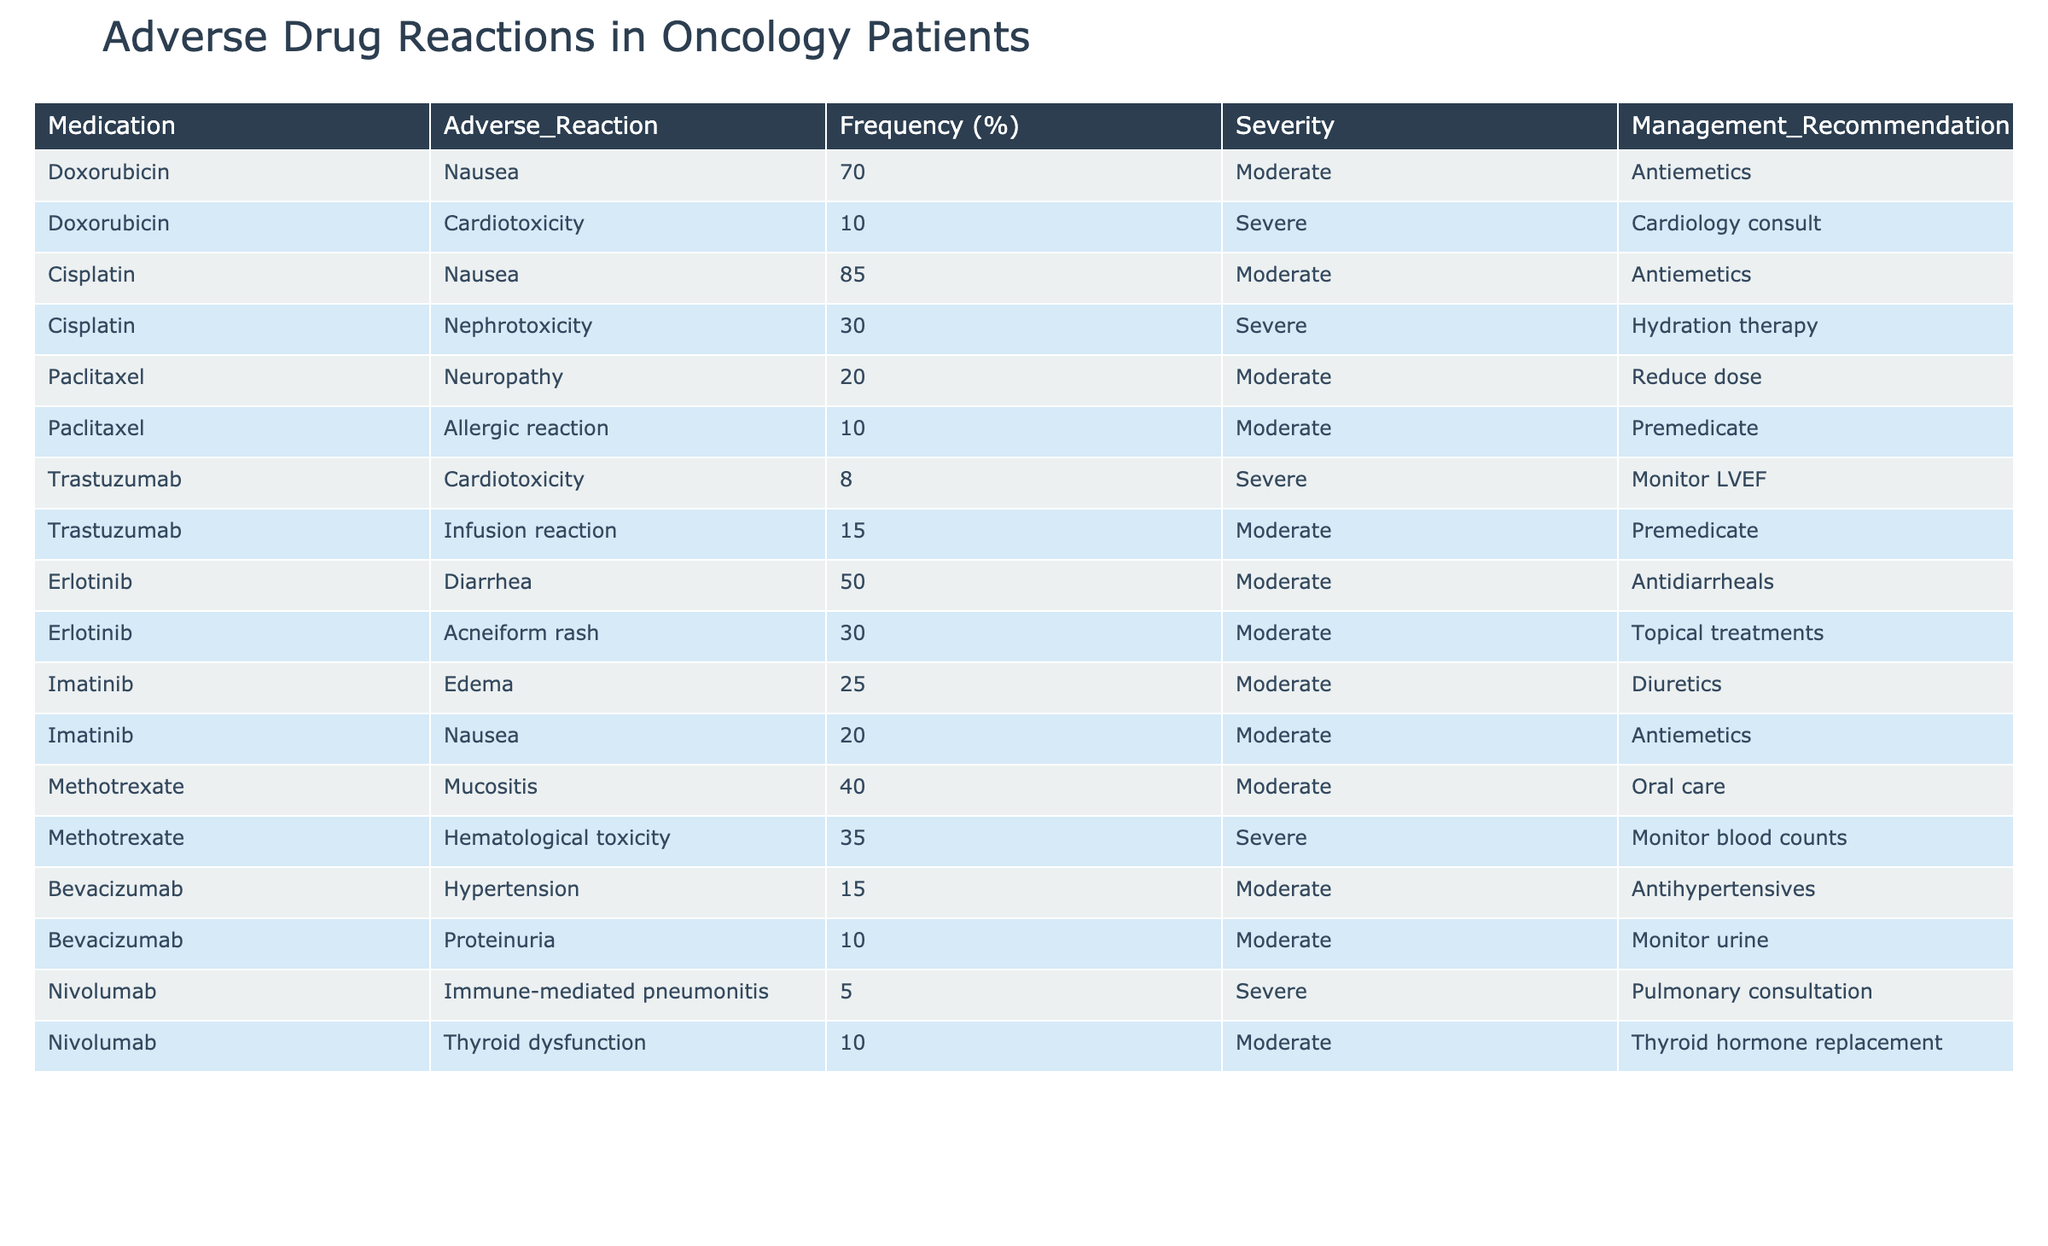What is the frequency of nausea as an adverse reaction to Cisplatin? The table shows that the frequency of nausea as an adverse reaction to Cisplatin is listed directly in the corresponding row, which is 85%.
Answer: 85% Which medication has the highest frequency of gastrointestinal adverse reactions? By examining the frequencies of gastrointestinal adverse reactions in the table, we see that both Doxorubicin and Cisplatin have nausea listed, with Cisplatin having a frequency of 85% for nausea. None of the other medications have a higher frequency for gastrointestinal issues. Therefore, the medication with the highest frequency of gastrointestinal adverse reactions is Cisplatin.
Answer: Cisplatin Is it true that all adverse reactions listed for Paclitaxel are of moderate severity? Looking at the table, both adverse reactions for Paclitaxel (Neuropathy and Allergic reaction) list a severity of moderate. Therefore, it is true that all adverse reactions for Paclitaxel are of moderate severity.
Answer: Yes What is the average frequency of adverse reactions for Imatinib? To find the average frequency, we take the two frequencies listed for Imatinib: 25% for Edema and 20% for Nausea. We sum these frequencies (25 + 20 = 45) and then divide by the number of reactions (2) to find the average: 45 / 2 = 22.5%.
Answer: 22.5% Which medication has the lowest frequency of adverse reactions and what are those reactions? The table shows that Nivolumab has adverse reactions listed with the lowest frequency; Immune-mediated pneumonitis at 5% and Thyroid dysfunction at 10%. Hence, the lowest frequency of adverse reactions is associated with Nivolumab.
Answer: Nivolumab; Immune-mediated pneumonitis (5%), Thyroid dysfunction (10%) 